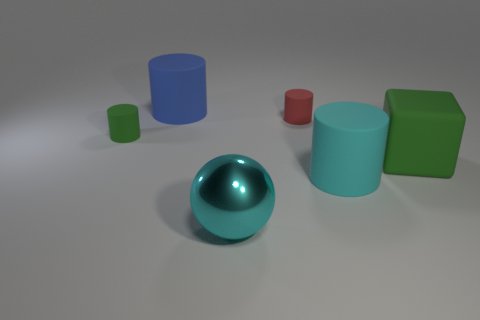How many other objects are there of the same color as the big metallic thing?
Keep it short and to the point. 1. Are there fewer cyan cylinders in front of the cyan metallic thing than green blocks that are left of the green block?
Offer a very short reply. No. How many things are large rubber cylinders in front of the tiny red matte object or tiny red metallic spheres?
Offer a very short reply. 1. There is a red thing; does it have the same size as the green thing that is behind the big green thing?
Your answer should be compact. Yes. The cyan object that is the same shape as the blue matte thing is what size?
Offer a very short reply. Large. How many large metallic spheres are behind the large object that is behind the tiny rubber object left of the large cyan sphere?
Your response must be concise. 0. What number of cylinders are either small green things or cyan rubber things?
Your answer should be compact. 2. What color is the large object behind the green rubber thing right of the green thing left of the large blue matte cylinder?
Your answer should be very brief. Blue. How many other objects are there of the same size as the green matte cylinder?
Your answer should be compact. 1. Is there any other thing that is the same shape as the large metallic object?
Keep it short and to the point. No. 